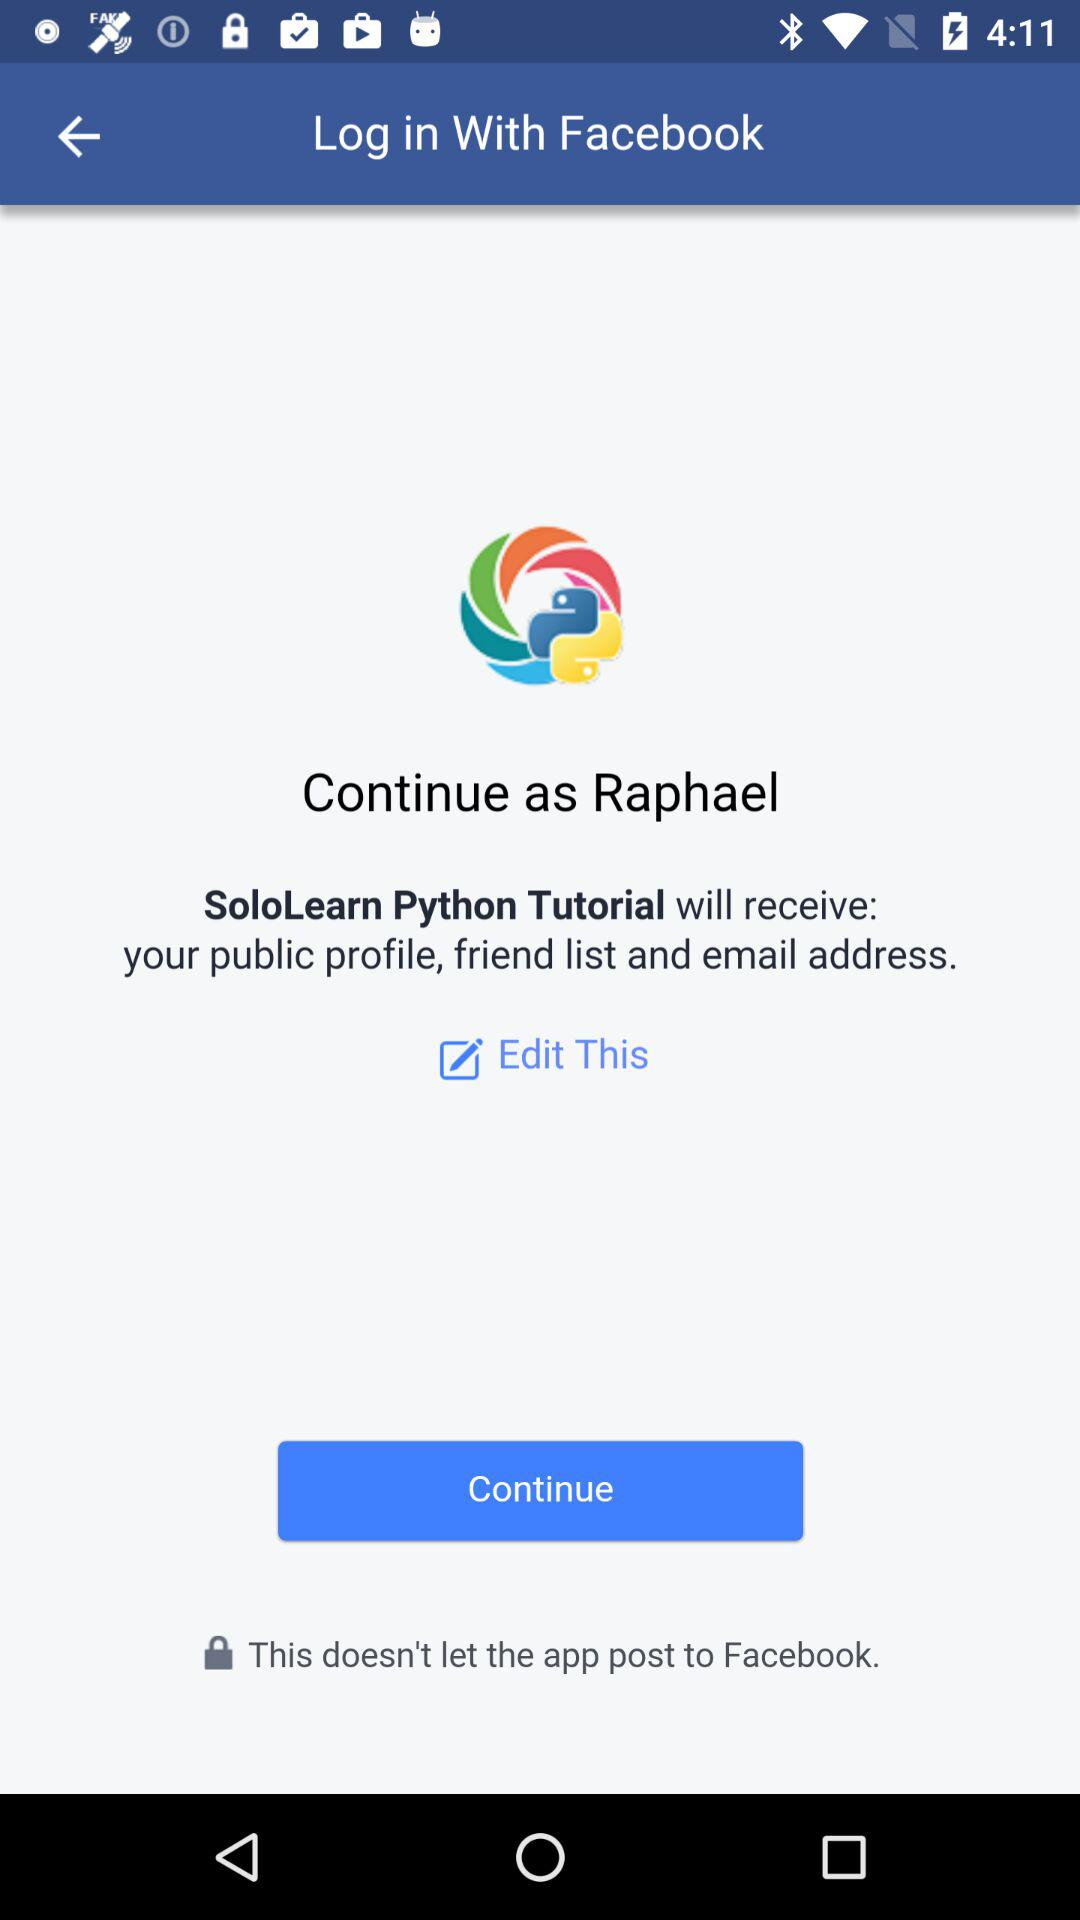What application will receive your public profile, friend list, and email address? The application that will receive the public profile, friend list, and email address is "SoloLearn Python Tutorial". 